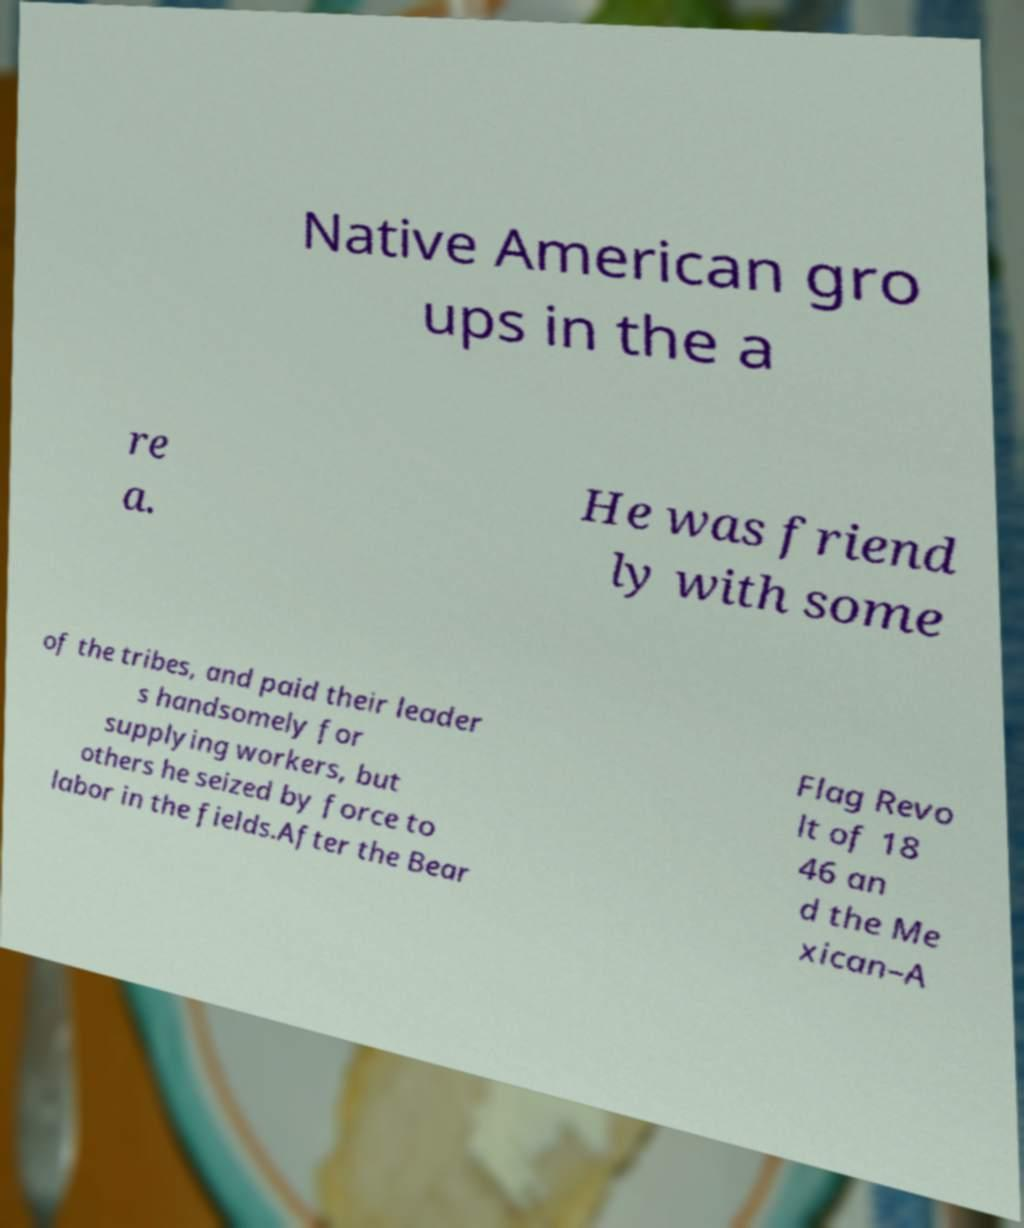Can you accurately transcribe the text from the provided image for me? Native American gro ups in the a re a. He was friend ly with some of the tribes, and paid their leader s handsomely for supplying workers, but others he seized by force to labor in the fields.After the Bear Flag Revo lt of 18 46 an d the Me xican–A 